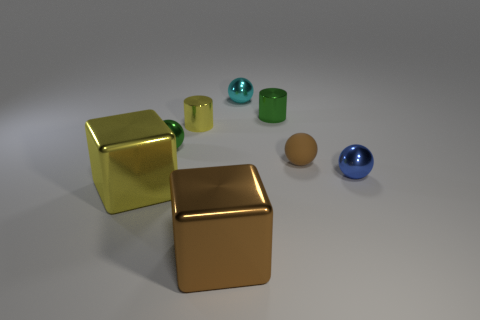Subtract all brown balls. How many balls are left? 3 Add 1 brown balls. How many objects exist? 9 Subtract all brown balls. How many balls are left? 3 Subtract all cylinders. How many objects are left? 6 Add 4 small cyan metal objects. How many small cyan metal objects are left? 5 Add 1 tiny green objects. How many tiny green objects exist? 3 Subtract 0 yellow spheres. How many objects are left? 8 Subtract all gray spheres. Subtract all cyan cubes. How many spheres are left? 4 Subtract all matte balls. Subtract all tiny yellow objects. How many objects are left? 6 